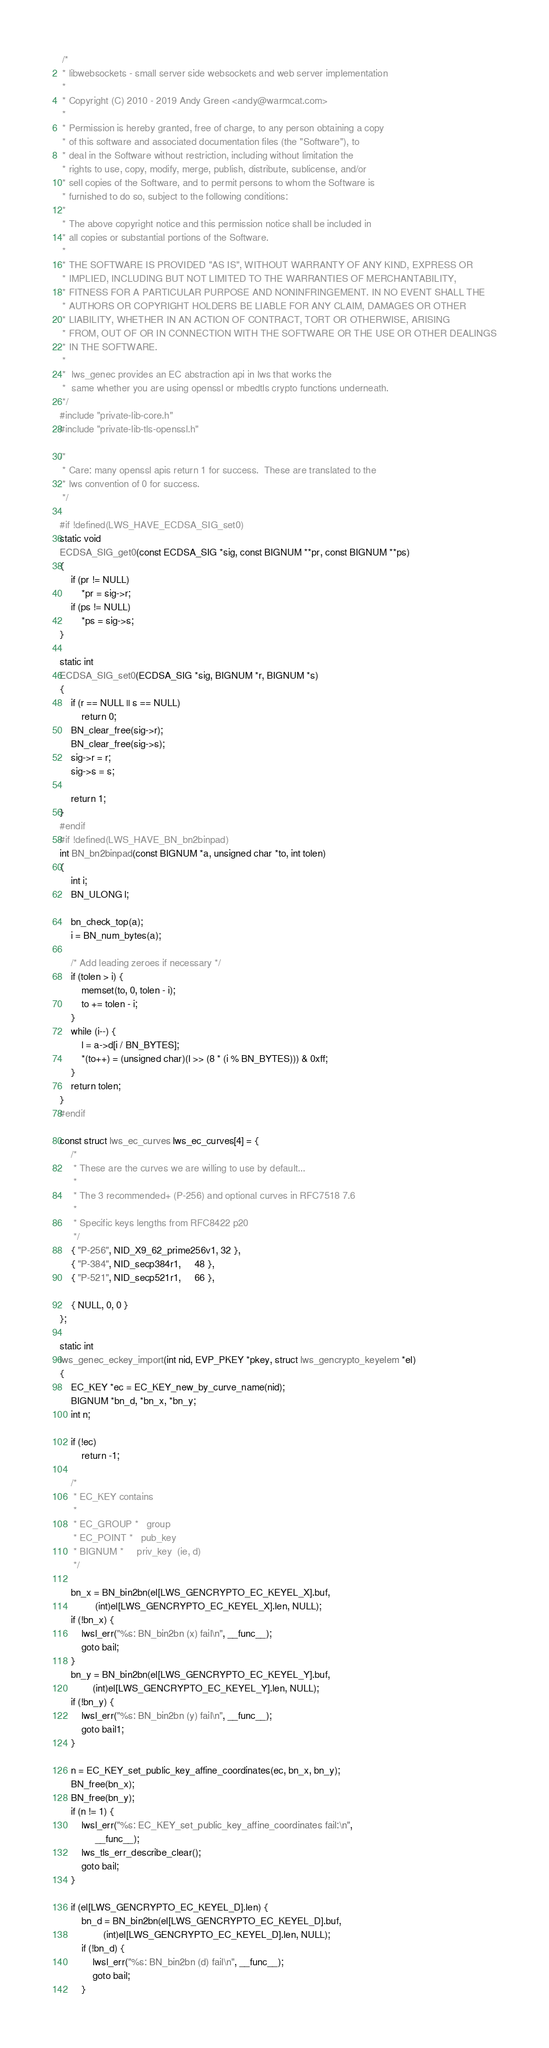Convert code to text. <code><loc_0><loc_0><loc_500><loc_500><_C_> /*
 * libwebsockets - small server side websockets and web server implementation
 *
 * Copyright (C) 2010 - 2019 Andy Green <andy@warmcat.com>
 *
 * Permission is hereby granted, free of charge, to any person obtaining a copy
 * of this software and associated documentation files (the "Software"), to
 * deal in the Software without restriction, including without limitation the
 * rights to use, copy, modify, merge, publish, distribute, sublicense, and/or
 * sell copies of the Software, and to permit persons to whom the Software is
 * furnished to do so, subject to the following conditions:
 *
 * The above copyright notice and this permission notice shall be included in
 * all copies or substantial portions of the Software.
 *
 * THE SOFTWARE IS PROVIDED "AS IS", WITHOUT WARRANTY OF ANY KIND, EXPRESS OR
 * IMPLIED, INCLUDING BUT NOT LIMITED TO THE WARRANTIES OF MERCHANTABILITY,
 * FITNESS FOR A PARTICULAR PURPOSE AND NONINFRINGEMENT. IN NO EVENT SHALL THE
 * AUTHORS OR COPYRIGHT HOLDERS BE LIABLE FOR ANY CLAIM, DAMAGES OR OTHER
 * LIABILITY, WHETHER IN AN ACTION OF CONTRACT, TORT OR OTHERWISE, ARISING
 * FROM, OUT OF OR IN CONNECTION WITH THE SOFTWARE OR THE USE OR OTHER DEALINGS
 * IN THE SOFTWARE.
 *
 *  lws_genec provides an EC abstraction api in lws that works the
 *  same whether you are using openssl or mbedtls crypto functions underneath.
 */
#include "private-lib-core.h"
#include "private-lib-tls-openssl.h"

/*
 * Care: many openssl apis return 1 for success.  These are translated to the
 * lws convention of 0 for success.
 */

#if !defined(LWS_HAVE_ECDSA_SIG_set0)
static void
ECDSA_SIG_get0(const ECDSA_SIG *sig, const BIGNUM **pr, const BIGNUM **ps)
{
    if (pr != NULL)
        *pr = sig->r;
    if (ps != NULL)
        *ps = sig->s;
}

static int
ECDSA_SIG_set0(ECDSA_SIG *sig, BIGNUM *r, BIGNUM *s)
{
	if (r == NULL || s == NULL)
		return 0;
	BN_clear_free(sig->r);
	BN_clear_free(sig->s);
	sig->r = r;
	sig->s = s;

	return 1;
}
#endif
#if !defined(LWS_HAVE_BN_bn2binpad)
int BN_bn2binpad(const BIGNUM *a, unsigned char *to, int tolen)
{
    int i;
    BN_ULONG l;

    bn_check_top(a);
    i = BN_num_bytes(a);

    /* Add leading zeroes if necessary */
    if (tolen > i) {
        memset(to, 0, tolen - i);
        to += tolen - i;
    }
    while (i--) {
        l = a->d[i / BN_BYTES];
        *(to++) = (unsigned char)(l >> (8 * (i % BN_BYTES))) & 0xff;
    }
    return tolen;
}
#endif

const struct lws_ec_curves lws_ec_curves[4] = {
	/*
	 * These are the curves we are willing to use by default...
	 *
	 * The 3 recommended+ (P-256) and optional curves in RFC7518 7.6
	 *
	 * Specific keys lengths from RFC8422 p20
	 */
	{ "P-256", NID_X9_62_prime256v1, 32 },
	{ "P-384", NID_secp384r1,	 48 },
	{ "P-521", NID_secp521r1,	 66 },

	{ NULL, 0, 0 }
};

static int
lws_genec_eckey_import(int nid, EVP_PKEY *pkey, struct lws_gencrypto_keyelem *el)
{
	EC_KEY *ec = EC_KEY_new_by_curve_name(nid);
	BIGNUM *bn_d, *bn_x, *bn_y;
	int n;

	if (!ec)
		return -1;

	/*
	 * EC_KEY contains
	 *
	 * EC_GROUP * 	group
	 * EC_POINT * 	pub_key
	 * BIGNUM * 	priv_key  (ie, d)
	 */

	bn_x = BN_bin2bn(el[LWS_GENCRYPTO_EC_KEYEL_X].buf,
			 (int)el[LWS_GENCRYPTO_EC_KEYEL_X].len, NULL);
	if (!bn_x) {
		lwsl_err("%s: BN_bin2bn (x) fail\n", __func__);
		goto bail;
	}
	bn_y = BN_bin2bn(el[LWS_GENCRYPTO_EC_KEYEL_Y].buf,
			(int)el[LWS_GENCRYPTO_EC_KEYEL_Y].len, NULL);
	if (!bn_y) {
		lwsl_err("%s: BN_bin2bn (y) fail\n", __func__);
		goto bail1;
	}

	n = EC_KEY_set_public_key_affine_coordinates(ec, bn_x, bn_y);
	BN_free(bn_x);
	BN_free(bn_y);
	if (n != 1) {
		lwsl_err("%s: EC_KEY_set_public_key_affine_coordinates fail:\n",
			 __func__);
		lws_tls_err_describe_clear();
		goto bail;
	}

	if (el[LWS_GENCRYPTO_EC_KEYEL_D].len) {
		bn_d = BN_bin2bn(el[LWS_GENCRYPTO_EC_KEYEL_D].buf,
				(int)el[LWS_GENCRYPTO_EC_KEYEL_D].len, NULL);
		if (!bn_d) {
			lwsl_err("%s: BN_bin2bn (d) fail\n", __func__);
			goto bail;
		}
</code> 